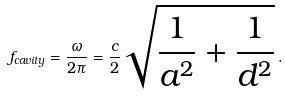<formula> <loc_0><loc_0><loc_500><loc_500>f _ { c a v i t y } = \frac { \omega } { 2 \pi } = \frac { c } { 2 } \sqrt { \frac { 1 } { a ^ { 2 } } + \frac { 1 } { d ^ { 2 } } } \, .</formula> 